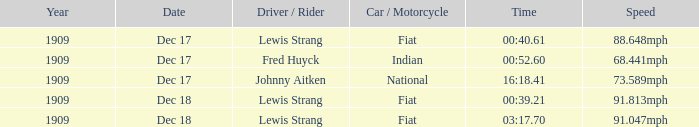Which driver is Indian? Fred Huyck. 